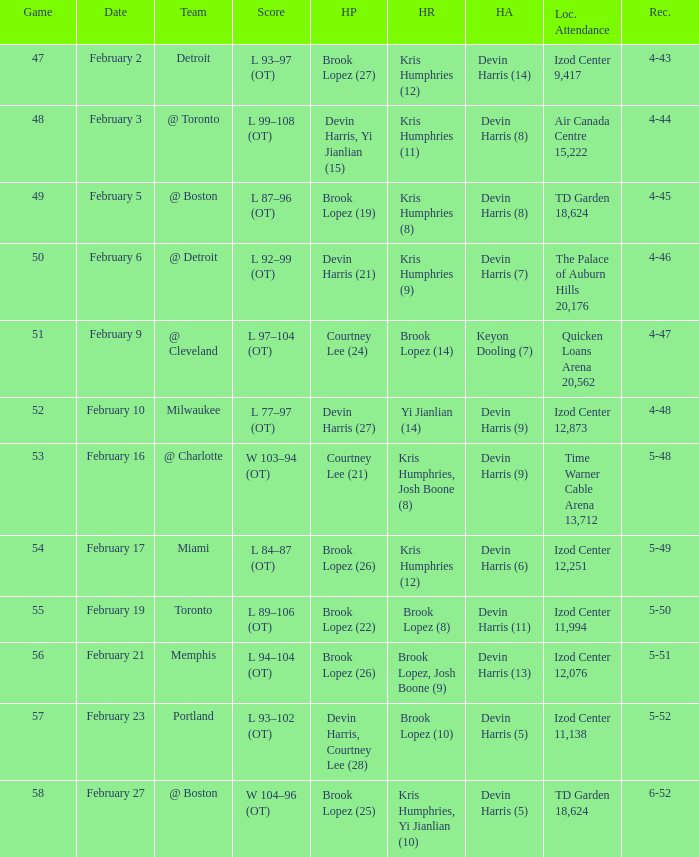Who did the high assists in the game played on February 9? Keyon Dooling (7). 